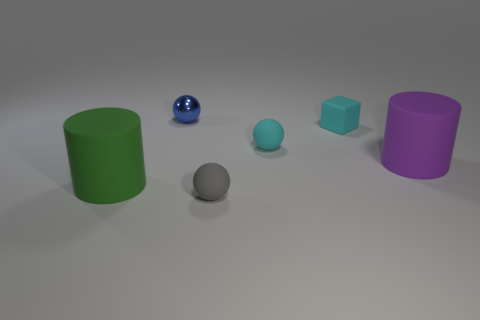Can you describe the arrangement of the objects from left to right? Certainly, from left to right, we observe a green cylinder, a reflective blue sphere, a small blue ball, a grey sphere, a turquoise cube, and lastly, a purple cylinder. Is there any pattern or symmetry in this arrangement? The arrangement does not seem to follow a specific pattern or exhibit symmetry. The objects vary in size, shape, and color, and are placed at varying intervals on the surface. 